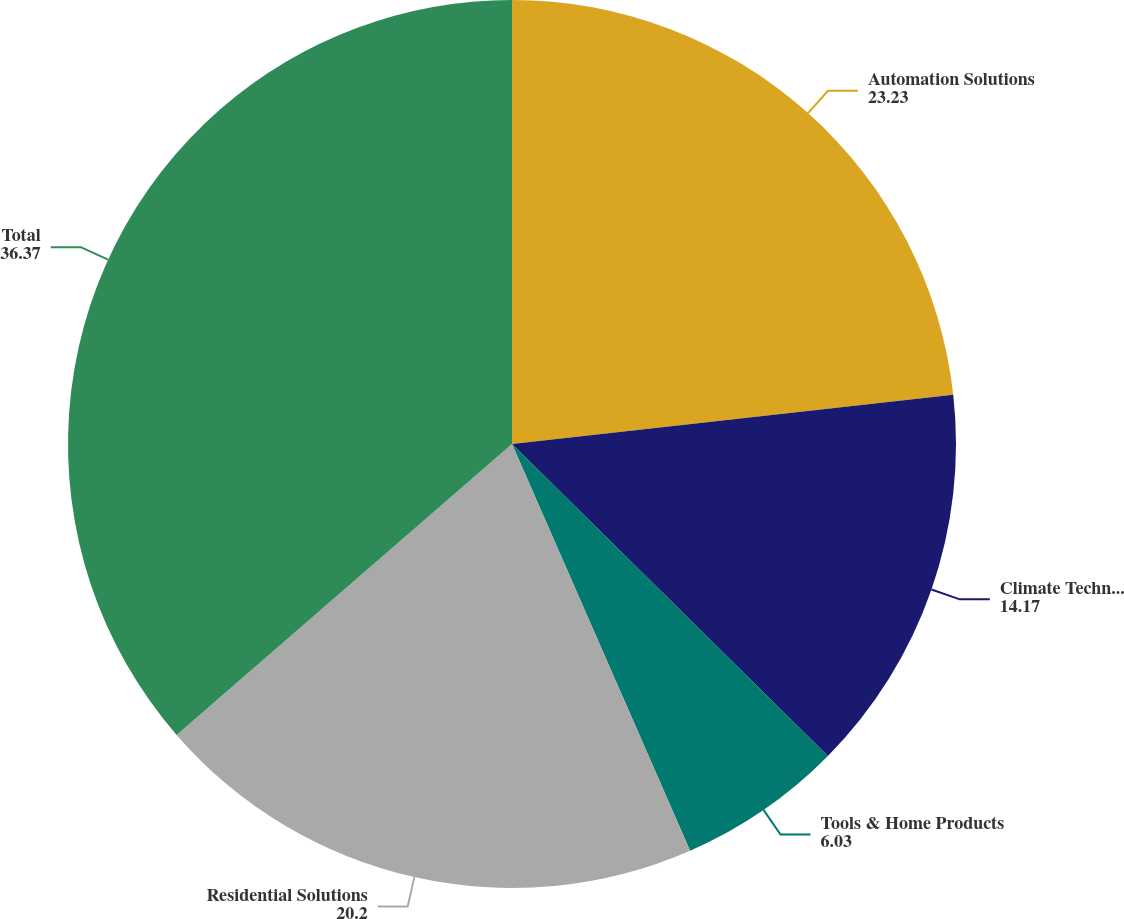Convert chart. <chart><loc_0><loc_0><loc_500><loc_500><pie_chart><fcel>Automation Solutions<fcel>Climate Technologies<fcel>Tools & Home Products<fcel>Residential Solutions<fcel>Total<nl><fcel>23.23%<fcel>14.17%<fcel>6.03%<fcel>20.2%<fcel>36.37%<nl></chart> 